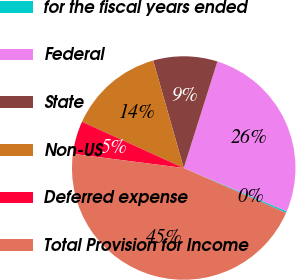Convert chart. <chart><loc_0><loc_0><loc_500><loc_500><pie_chart><fcel>for the fiscal years ended<fcel>Federal<fcel>State<fcel>Non-US<fcel>Deferred expense<fcel>Total Provision for Income<nl><fcel>0.24%<fcel>26.45%<fcel>9.28%<fcel>13.81%<fcel>4.76%<fcel>45.46%<nl></chart> 